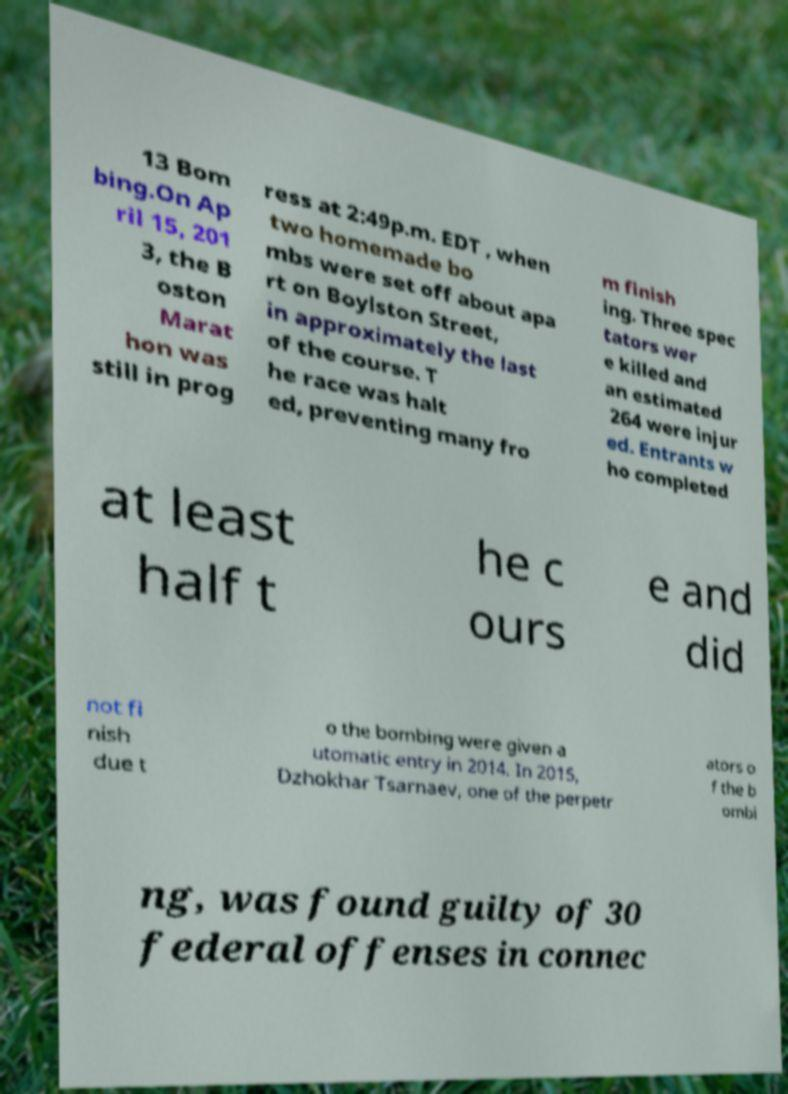Please identify and transcribe the text found in this image. 13 Bom bing.On Ap ril 15, 201 3, the B oston Marat hon was still in prog ress at 2:49p.m. EDT , when two homemade bo mbs were set off about apa rt on Boylston Street, in approximately the last of the course. T he race was halt ed, preventing many fro m finish ing. Three spec tators wer e killed and an estimated 264 were injur ed. Entrants w ho completed at least half t he c ours e and did not fi nish due t o the bombing were given a utomatic entry in 2014. In 2015, Dzhokhar Tsarnaev, one of the perpetr ators o f the b ombi ng, was found guilty of 30 federal offenses in connec 